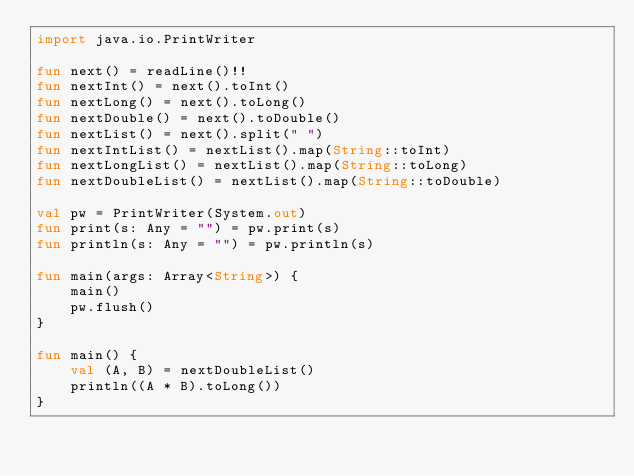<code> <loc_0><loc_0><loc_500><loc_500><_Kotlin_>import java.io.PrintWriter

fun next() = readLine()!!
fun nextInt() = next().toInt()
fun nextLong() = next().toLong()
fun nextDouble() = next().toDouble()
fun nextList() = next().split(" ")
fun nextIntList() = nextList().map(String::toInt)
fun nextLongList() = nextList().map(String::toLong)
fun nextDoubleList() = nextList().map(String::toDouble)

val pw = PrintWriter(System.out)
fun print(s: Any = "") = pw.print(s)
fun println(s: Any = "") = pw.println(s)

fun main(args: Array<String>) {
    main()
    pw.flush()
}

fun main() {
    val (A, B) = nextDoubleList()
    println((A * B).toLong())
}</code> 